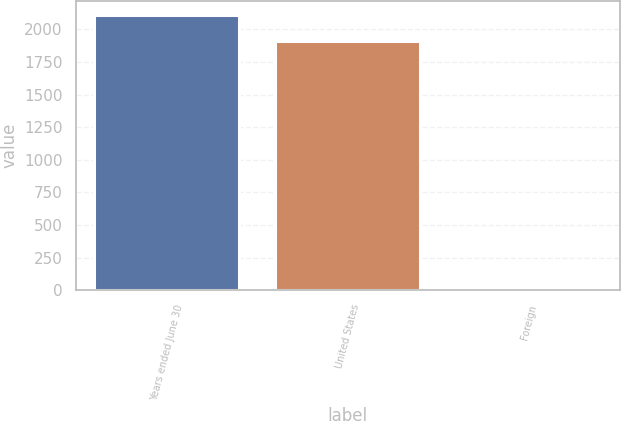Convert chart to OTSL. <chart><loc_0><loc_0><loc_500><loc_500><bar_chart><fcel>Years ended June 30<fcel>United States<fcel>Foreign<nl><fcel>2108.65<fcel>1908.6<fcel>8.5<nl></chart> 